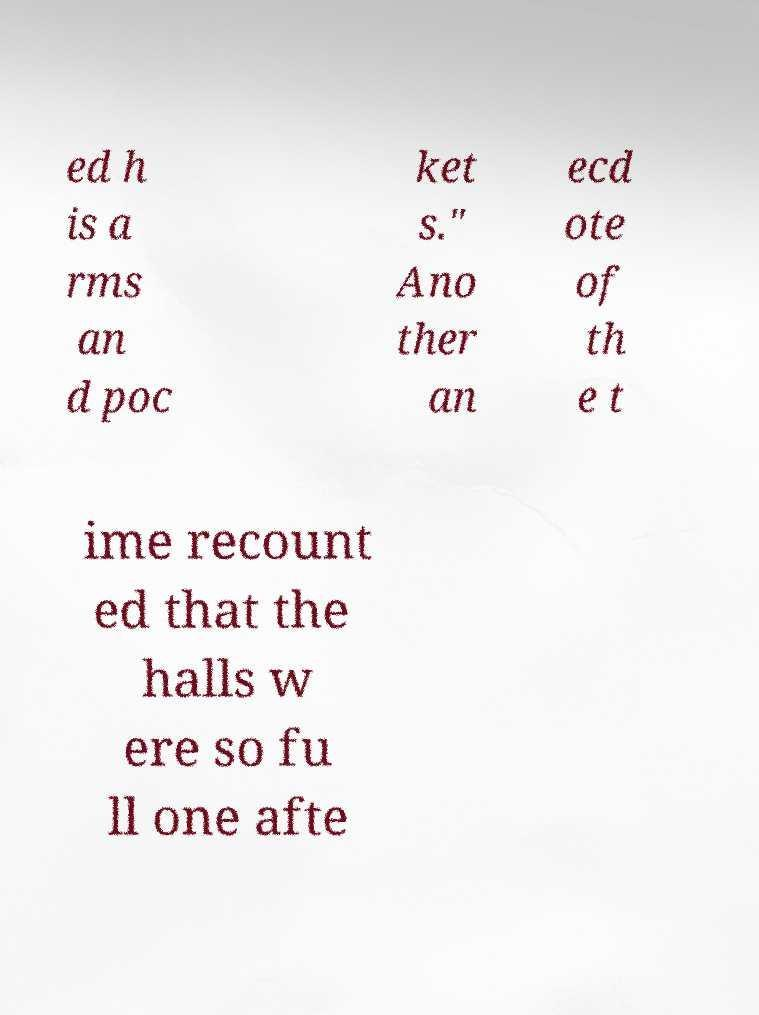Could you assist in decoding the text presented in this image and type it out clearly? ed h is a rms an d poc ket s." Ano ther an ecd ote of th e t ime recount ed that the halls w ere so fu ll one afte 